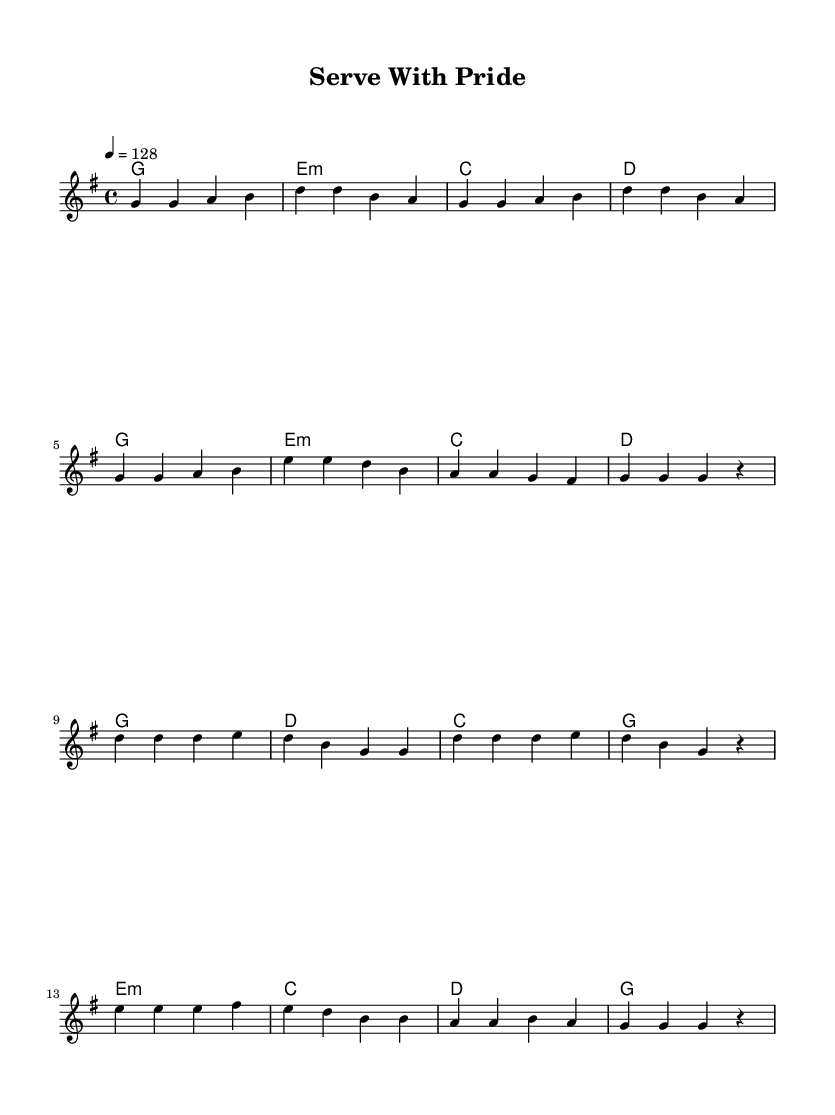What is the key signature of this music? The key signature is indicated at the beginning of the staff; it shows one sharp, indicating that the piece is in G major.
Answer: G major What is the time signature of this music? The time signature is located at the beginning of the score; it shows the upper '4' and the lower '4', indicating that it is in 4/4 time.
Answer: 4/4 What is the tempo marking of this piece? The tempo is specified at the beginning with "4 = 128", indicating the piece should be played at a speed of 128 beats per minute.
Answer: 128 How many parts are there in the score? The score includes two parts: the melody and the chord names shown in a separate staff. This can be seen by the two sections labeled in the score layout.
Answer: Two What is the chord progression in the chorus? By analyzing the harmonies listed under the chorus section, the chords are G, D, C, and G for the first half, followed by E minor, C, D, and G for the second half. The progression is played alongside the melody.
Answer: G, D, C, G, E minor, C, D, G What musical genre does this piece belong to? The style of the music, indicated by the upbeat tempo, catchy melody, and thematic content centered on civic duty, suggests it belongs to K-Pop, which is known for its energetic and catchy tracks.
Answer: K-Pop What is the highest note in the melody? Analyzing the melody, the highest note is indicated as D' in the chorus, which is the only occurrence of a note in the second octave, making it distinct from the others.
Answer: D 